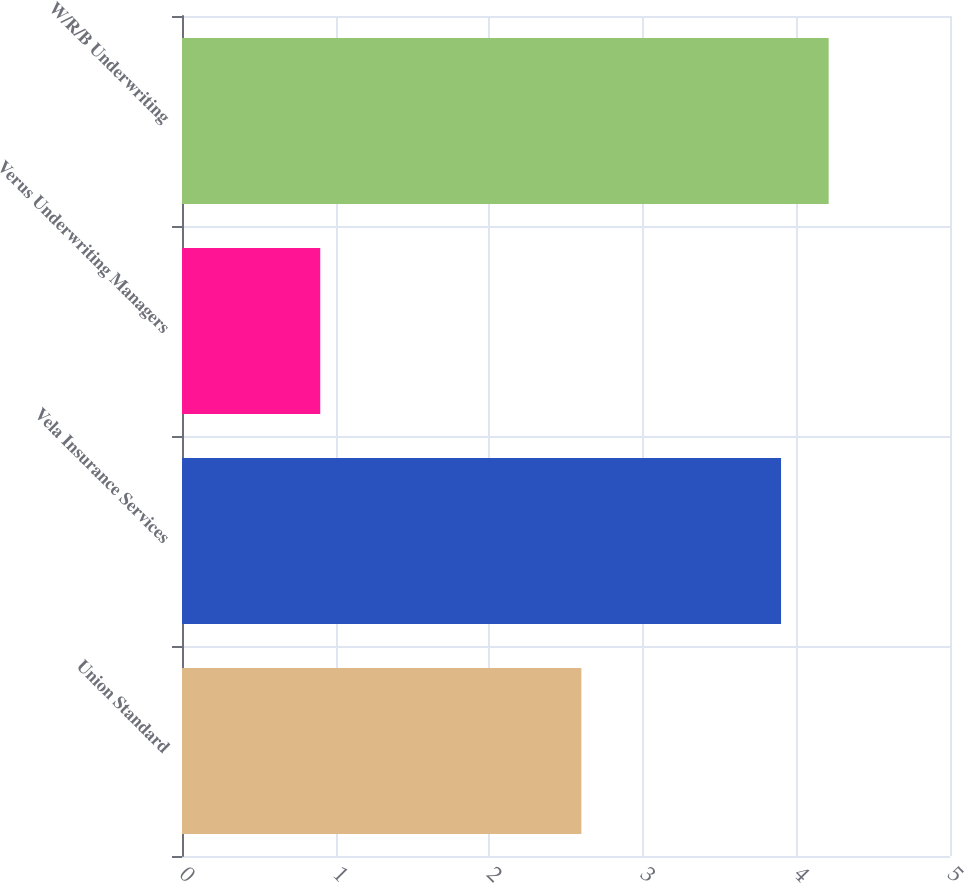<chart> <loc_0><loc_0><loc_500><loc_500><bar_chart><fcel>Union Standard<fcel>Vela Insurance Services<fcel>Verus Underwriting Managers<fcel>W/R/B Underwriting<nl><fcel>2.6<fcel>3.9<fcel>0.9<fcel>4.21<nl></chart> 